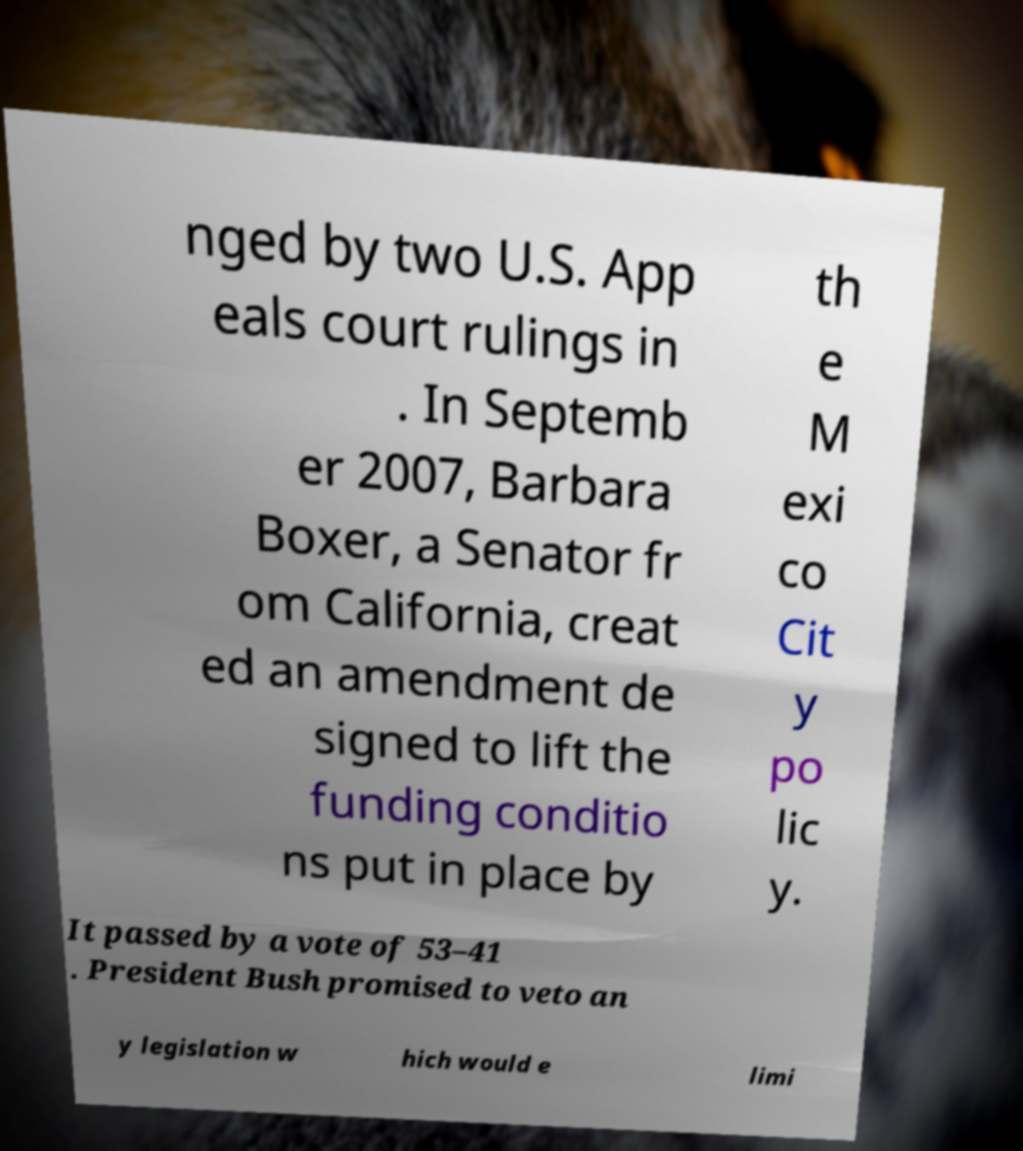Could you assist in decoding the text presented in this image and type it out clearly? nged by two U.S. App eals court rulings in . In Septemb er 2007, Barbara Boxer, a Senator fr om California, creat ed an amendment de signed to lift the funding conditio ns put in place by th e M exi co Cit y po lic y. It passed by a vote of 53–41 . President Bush promised to veto an y legislation w hich would e limi 